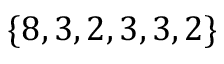Convert formula to latex. <formula><loc_0><loc_0><loc_500><loc_500>\{ 8 , 3 , 2 , 3 , 3 , 2 \}</formula> 